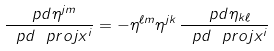<formula> <loc_0><loc_0><loc_500><loc_500>\frac { \ p d \eta ^ { j m } } { \ p d \ p r o j { x } ^ { i } } = - \eta ^ { \ell m } \eta ^ { j k } \, \frac { \ p d \eta _ { k \ell } } { \ p d \ p r o j { x } ^ { i } }</formula> 